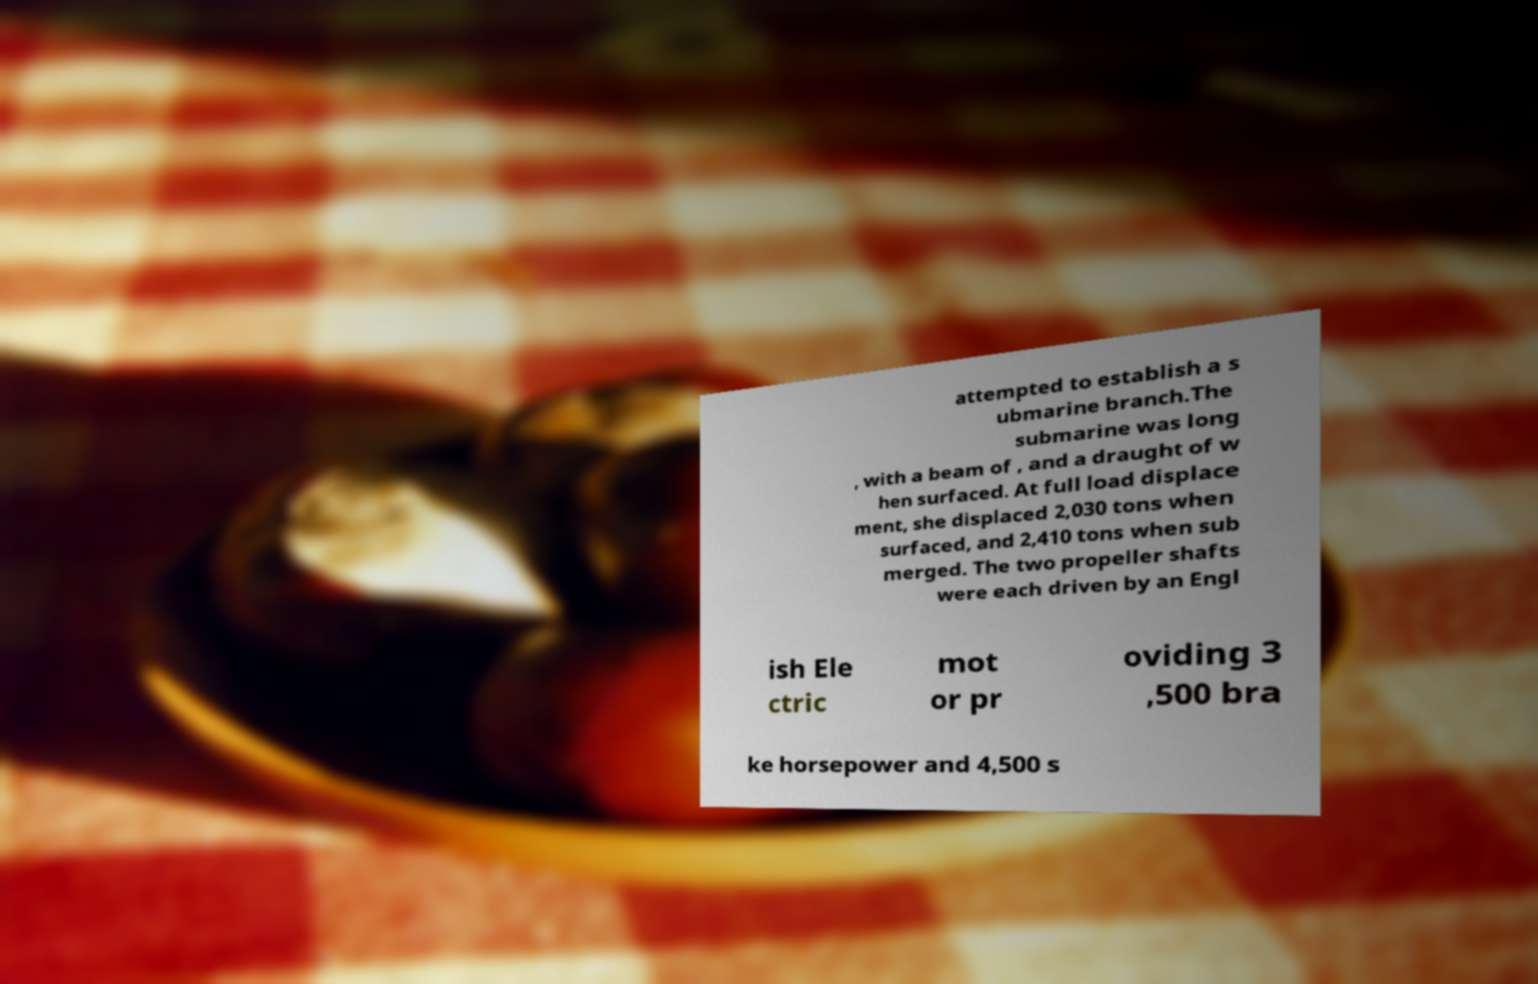Can you accurately transcribe the text from the provided image for me? attempted to establish a s ubmarine branch.The submarine was long , with a beam of , and a draught of w hen surfaced. At full load displace ment, she displaced 2,030 tons when surfaced, and 2,410 tons when sub merged. The two propeller shafts were each driven by an Engl ish Ele ctric mot or pr oviding 3 ,500 bra ke horsepower and 4,500 s 